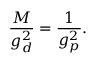Convert formula to latex. <formula><loc_0><loc_0><loc_500><loc_500>\frac { M } { g _ { d } ^ { 2 } } = \frac { 1 } { g _ { p } ^ { 2 } } .</formula> 